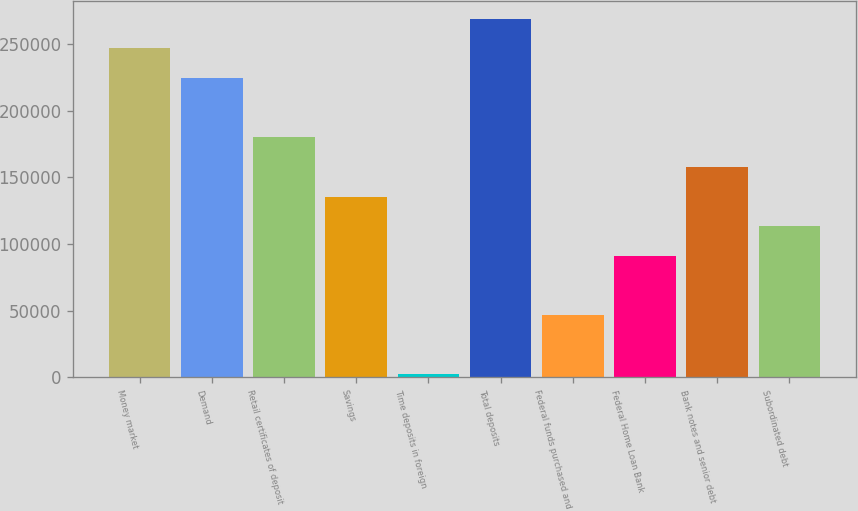Convert chart to OTSL. <chart><loc_0><loc_0><loc_500><loc_500><bar_chart><fcel>Money market<fcel>Demand<fcel>Retail certificates of deposit<fcel>Savings<fcel>Time deposits in foreign<fcel>Total deposits<fcel>Federal funds purchased and<fcel>Federal Home Loan Bank<fcel>Bank notes and senior debt<fcel>Subordinated debt<nl><fcel>246926<fcel>224670<fcel>180159<fcel>135648<fcel>2114<fcel>269181<fcel>46625.2<fcel>91136.4<fcel>157903<fcel>113392<nl></chart> 